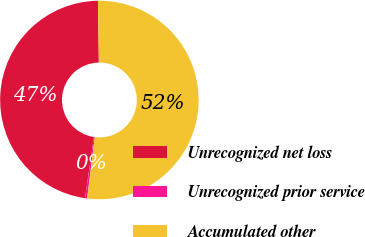Convert chart. <chart><loc_0><loc_0><loc_500><loc_500><pie_chart><fcel>Unrecognized net loss<fcel>Unrecognized prior service<fcel>Accumulated other<nl><fcel>47.45%<fcel>0.35%<fcel>52.2%<nl></chart> 